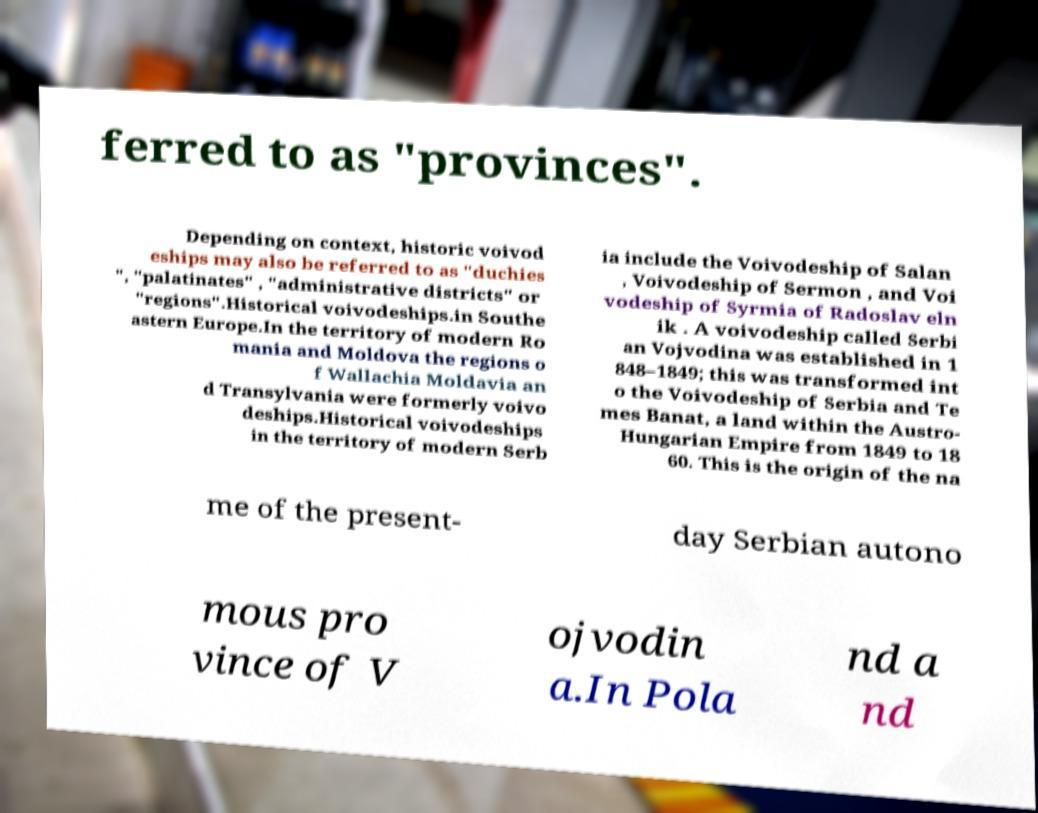There's text embedded in this image that I need extracted. Can you transcribe it verbatim? ferred to as "provinces". Depending on context, historic voivod eships may also be referred to as "duchies ", "palatinates" , "administrative districts" or "regions".Historical voivodeships.in Southe astern Europe.In the territory of modern Ro mania and Moldova the regions o f Wallachia Moldavia an d Transylvania were formerly voivo deships.Historical voivodeships in the territory of modern Serb ia include the Voivodeship of Salan , Voivodeship of Sermon , and Voi vodeship of Syrmia of Radoslav eln ik . A voivodeship called Serbi an Vojvodina was established in 1 848–1849; this was transformed int o the Voivodeship of Serbia and Te mes Banat, a land within the Austro- Hungarian Empire from 1849 to 18 60. This is the origin of the na me of the present- day Serbian autono mous pro vince of V ojvodin a.In Pola nd a nd 